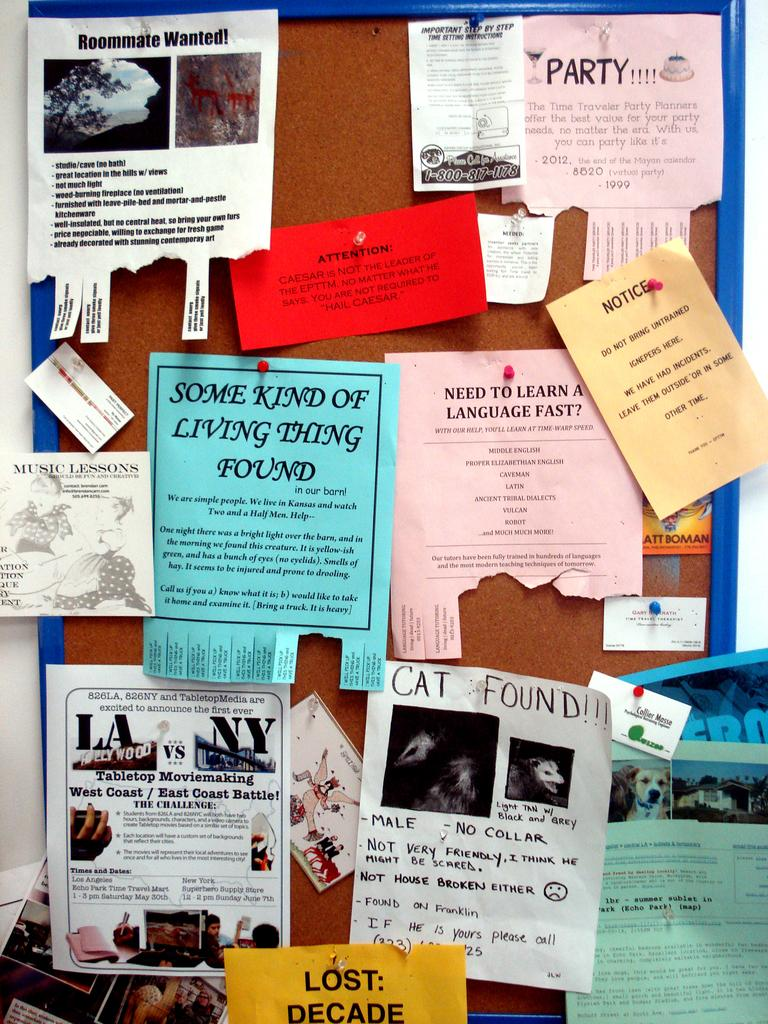Provide a one-sentence caption for the provided image. a paper that says a cat was found. 